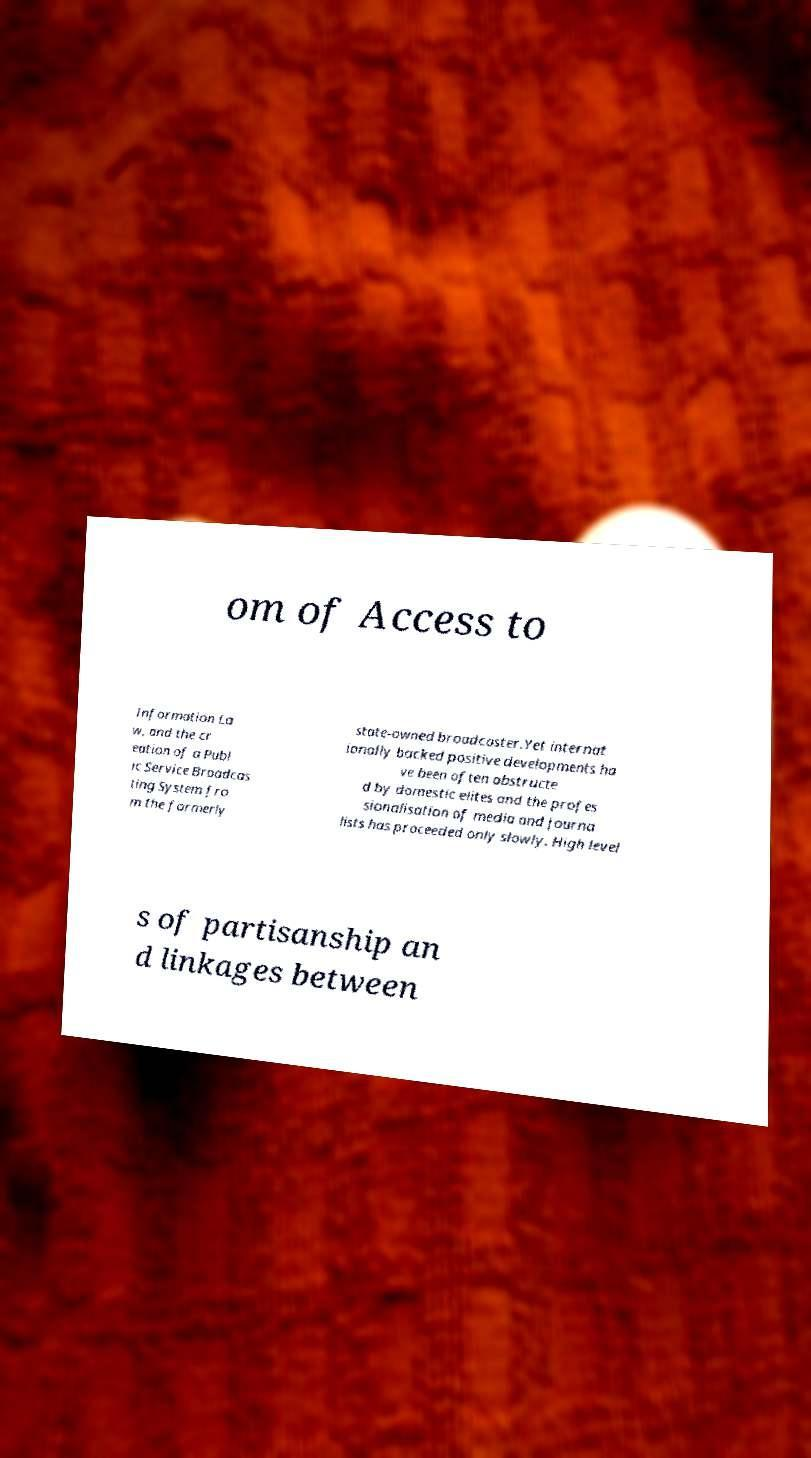Could you extract and type out the text from this image? om of Access to Information La w, and the cr eation of a Publ ic Service Broadcas ting System fro m the formerly state-owned broadcaster.Yet internat ionally backed positive developments ha ve been often obstructe d by domestic elites and the profes sionalisation of media and journa lists has proceeded only slowly. High level s of partisanship an d linkages between 